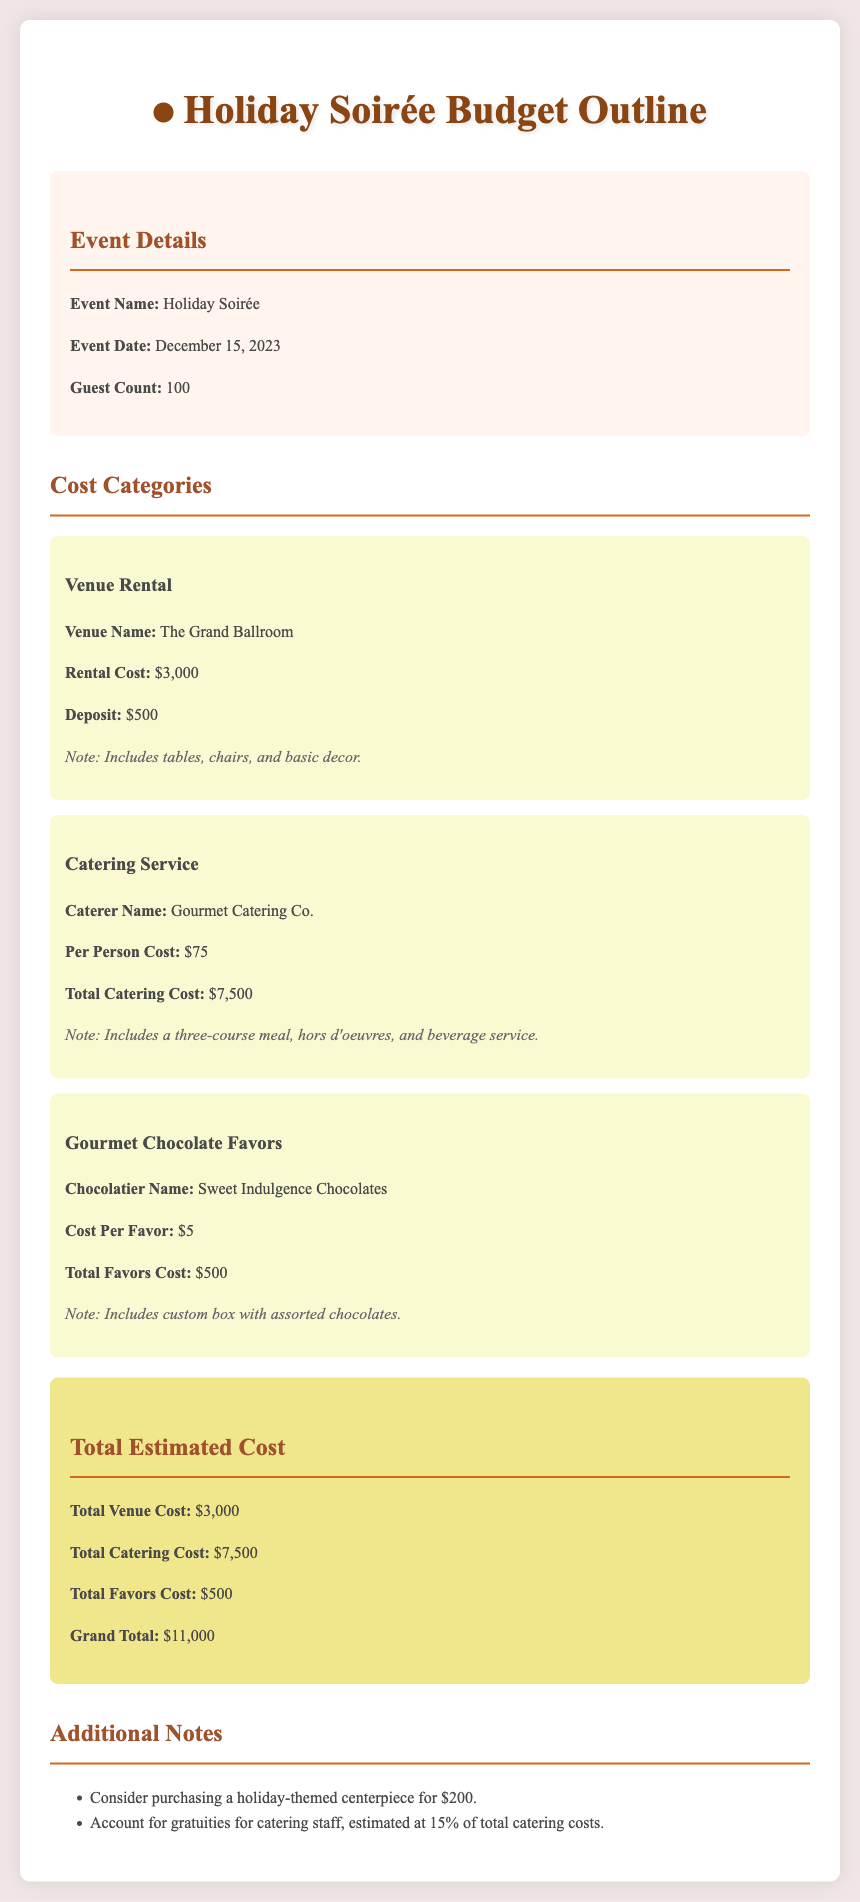What is the event name? The document specifies the event name at the top of the event details section.
Answer: Holiday Soirée What is the total catering cost? The total catering cost is found in the catering service cost category.
Answer: $7,500 What are the gourmet chocolate favors' total costs? The total cost of gourmet chocolate favors is provided under that specific category in the document.
Answer: $500 How many guests are expected? The number of guests is mentioned in the event details section.
Answer: 100 What is the per person cost for catering? The per person cost is indicated within the catering service portion of the document.
Answer: $75 What is the deposit amount for the venue? The deposit amount is stated in the venue rental section.
Answer: $500 What is the grand total estimated cost? The grand total is summarized at the end of the total estimated cost section.
Answer: $11,000 What additional item is suggested for purchase? The additional notes at the end of the document provide details about an additional item.
Answer: Holiday-themed centerpiece What percentage is suggested for gratuities? The document mentions the estimated gratuity percentage in the additional notes section.
Answer: 15% 